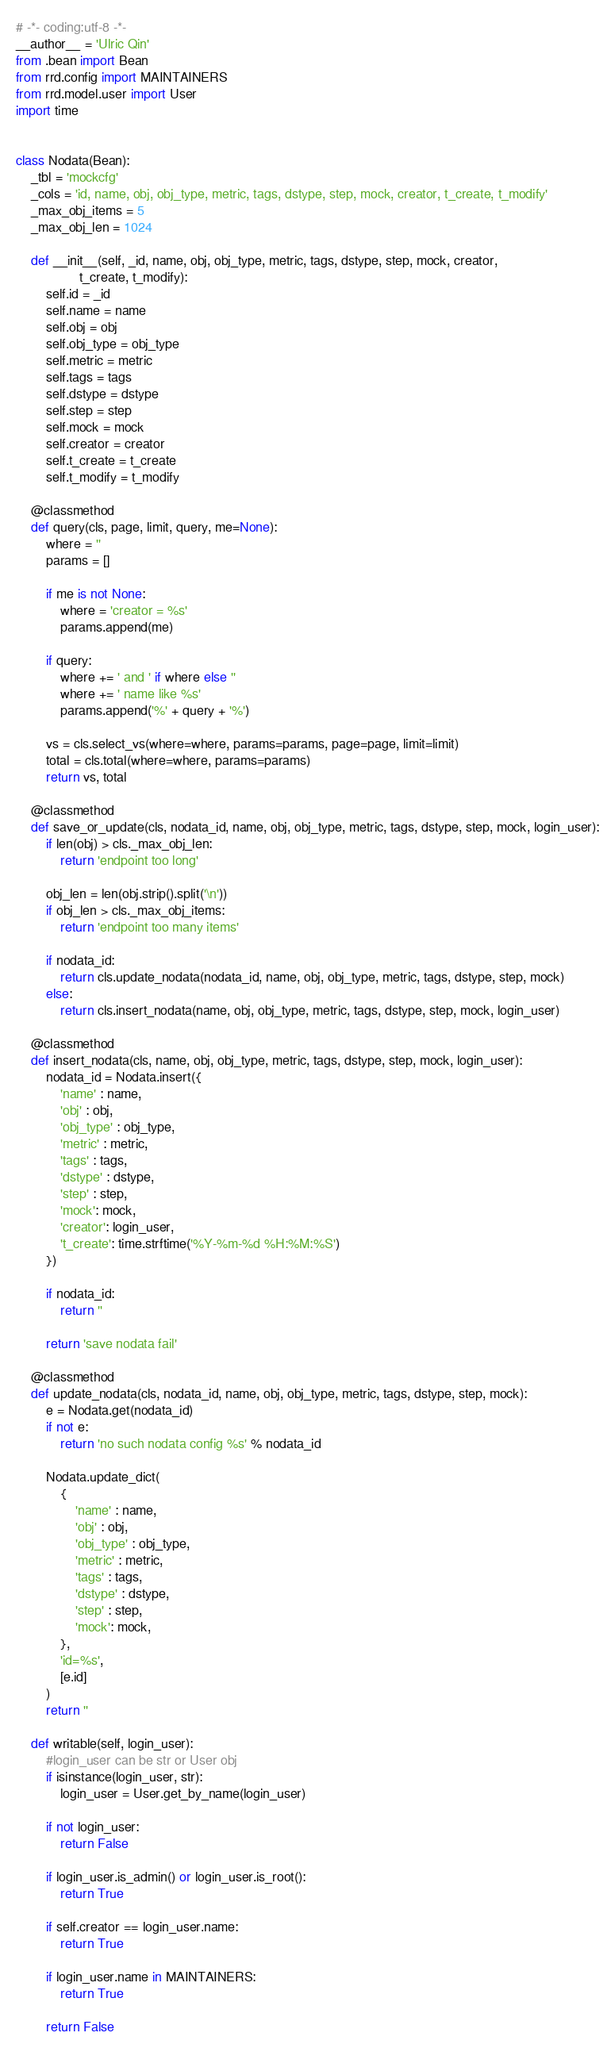<code> <loc_0><loc_0><loc_500><loc_500><_Python_># -*- coding:utf-8 -*-
__author__ = 'Ulric Qin'
from .bean import Bean
from rrd.config import MAINTAINERS
from rrd.model.user import User
import time


class Nodata(Bean):
    _tbl = 'mockcfg'
    _cols = 'id, name, obj, obj_type, metric, tags, dstype, step, mock, creator, t_create, t_modify'
    _max_obj_items = 5
    _max_obj_len = 1024

    def __init__(self, _id, name, obj, obj_type, metric, tags, dstype, step, mock, creator,
                 t_create, t_modify):
        self.id = _id
        self.name = name
        self.obj = obj
        self.obj_type = obj_type
        self.metric = metric
        self.tags = tags
        self.dstype = dstype
        self.step = step
        self.mock = mock
        self.creator = creator
        self.t_create = t_create
        self.t_modify = t_modify
 
    @classmethod
    def query(cls, page, limit, query, me=None):
        where = ''
        params = []

        if me is not None:
            where = 'creator = %s'
            params.append(me)

        if query:
            where += ' and ' if where else ''
            where += ' name like %s'
            params.append('%' + query + '%')

        vs = cls.select_vs(where=where, params=params, page=page, limit=limit)
        total = cls.total(where=where, params=params)
        return vs, total

    @classmethod
    def save_or_update(cls, nodata_id, name, obj, obj_type, metric, tags, dstype, step, mock, login_user):
        if len(obj) > cls._max_obj_len:
            return 'endpoint too long'

        obj_len = len(obj.strip().split('\n'))
        if obj_len > cls._max_obj_items:
            return 'endpoint too many items'

        if nodata_id:
            return cls.update_nodata(nodata_id, name, obj, obj_type, metric, tags, dstype, step, mock)
        else:
            return cls.insert_nodata(name, obj, obj_type, metric, tags, dstype, step, mock, login_user)

    @classmethod
    def insert_nodata(cls, name, obj, obj_type, metric, tags, dstype, step, mock, login_user):
        nodata_id = Nodata.insert({
            'name' : name,
            'obj' : obj,
            'obj_type' : obj_type,
            'metric' : metric,
            'tags' : tags,
            'dstype' : dstype,
            'step' : step,
            'mock': mock,
            'creator': login_user,
            't_create': time.strftime('%Y-%m-%d %H:%M:%S')
        })

        if nodata_id:
            return ''

        return 'save nodata fail'

    @classmethod
    def update_nodata(cls, nodata_id, name, obj, obj_type, metric, tags, dstype, step, mock):
        e = Nodata.get(nodata_id)
        if not e:
            return 'no such nodata config %s' % nodata_id

        Nodata.update_dict(
            {
                'name' : name,
                'obj' : obj,
                'obj_type' : obj_type,
                'metric' : metric,
                'tags' : tags,
                'dstype' : dstype,
                'step' : step,
                'mock': mock,
            },
            'id=%s',
            [e.id]
        )
        return ''

    def writable(self, login_user):
        #login_user can be str or User obj
        if isinstance(login_user, str):
            login_user = User.get_by_name(login_user)

        if not login_user:
            return False

        if login_user.is_admin() or login_user.is_root():
            return True

        if self.creator == login_user.name:
            return True

        if login_user.name in MAINTAINERS:
            return True

        return False
</code> 